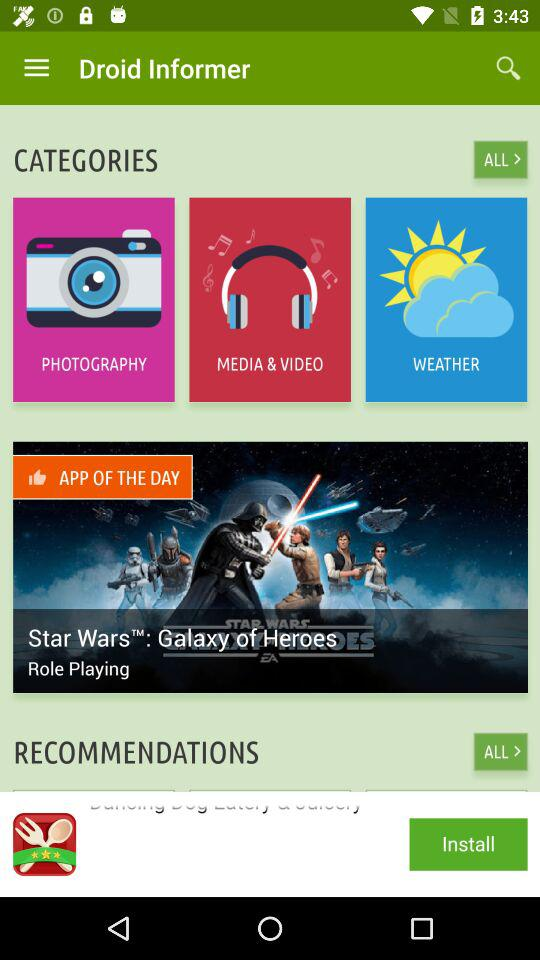What is the application name? The application name is "Droid Informer". 